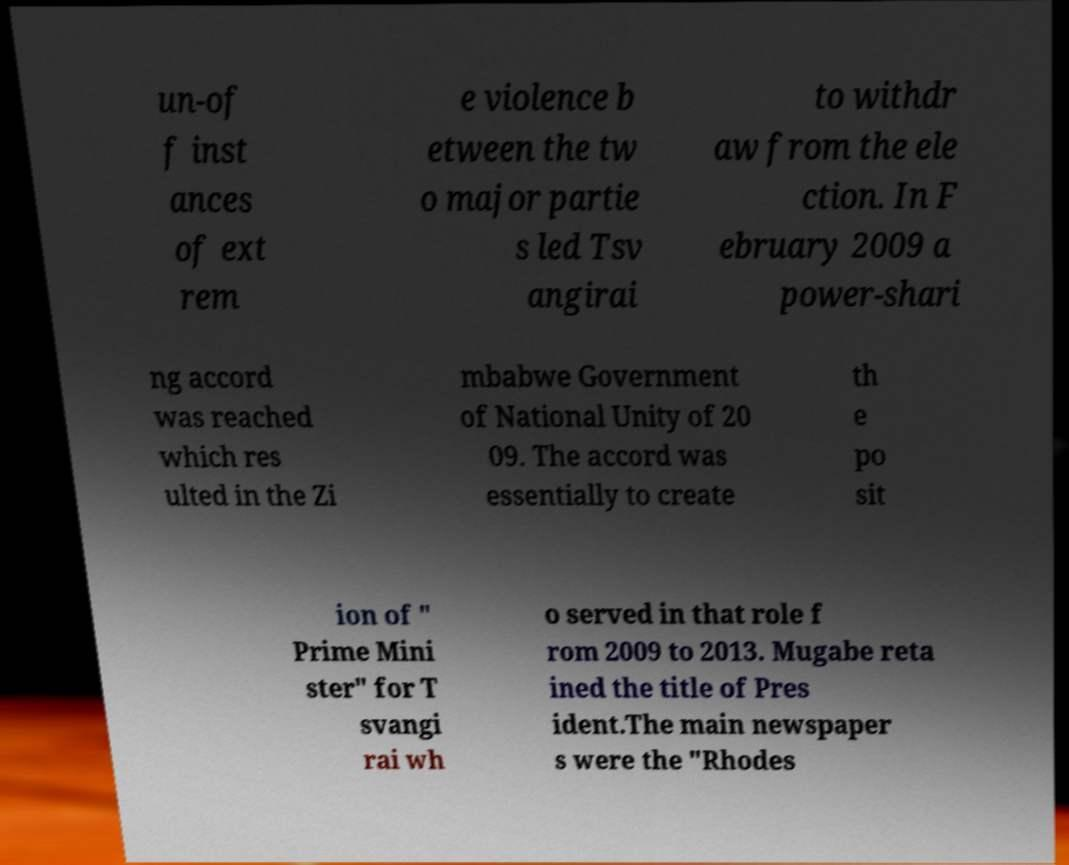Can you accurately transcribe the text from the provided image for me? un-of f inst ances of ext rem e violence b etween the tw o major partie s led Tsv angirai to withdr aw from the ele ction. In F ebruary 2009 a power-shari ng accord was reached which res ulted in the Zi mbabwe Government of National Unity of 20 09. The accord was essentially to create th e po sit ion of " Prime Mini ster" for T svangi rai wh o served in that role f rom 2009 to 2013. Mugabe reta ined the title of Pres ident.The main newspaper s were the "Rhodes 